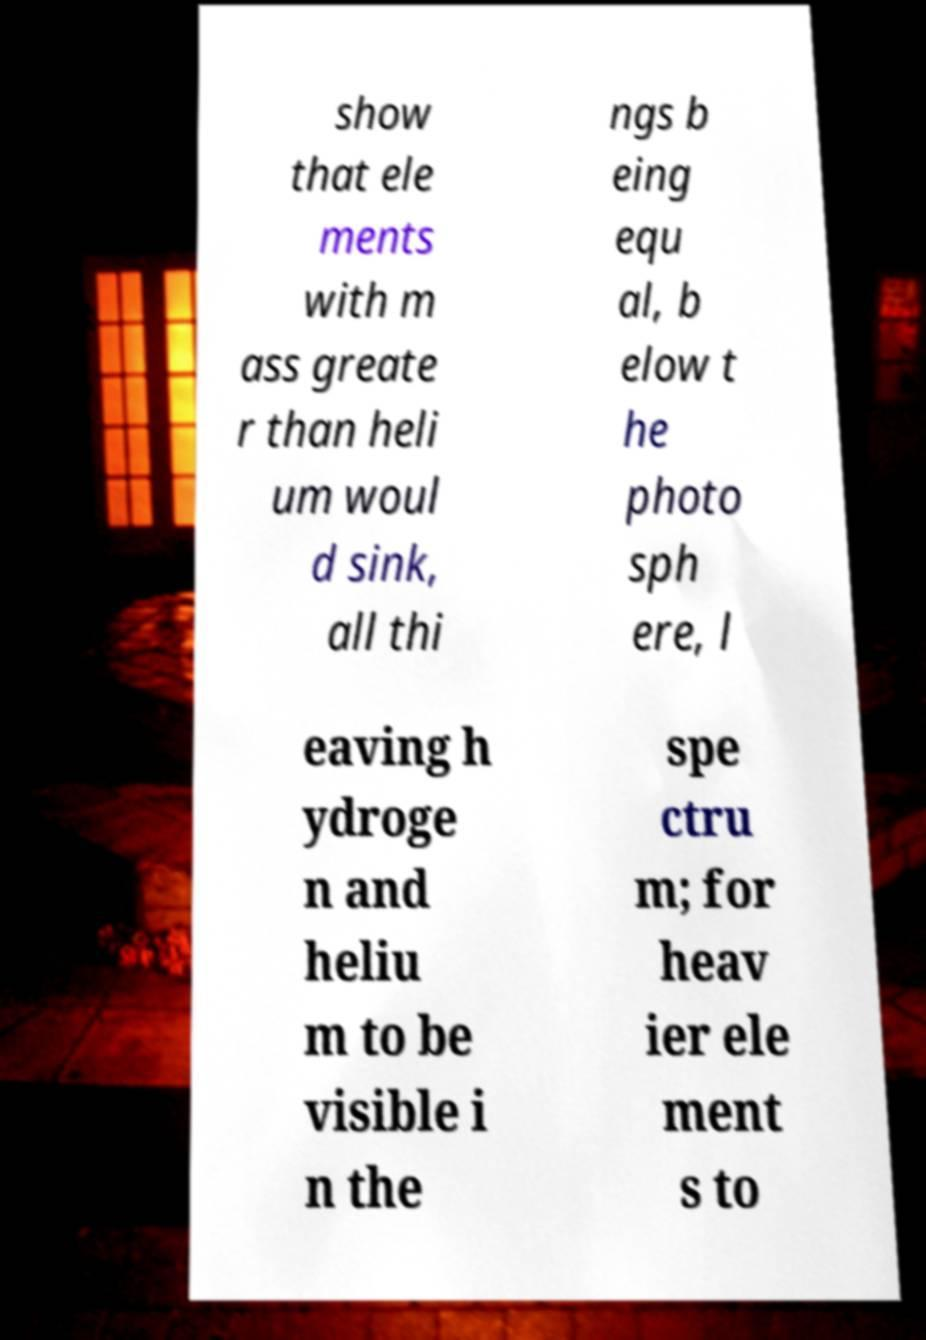Can you read and provide the text displayed in the image?This photo seems to have some interesting text. Can you extract and type it out for me? show that ele ments with m ass greate r than heli um woul d sink, all thi ngs b eing equ al, b elow t he photo sph ere, l eaving h ydroge n and heliu m to be visible i n the spe ctru m; for heav ier ele ment s to 